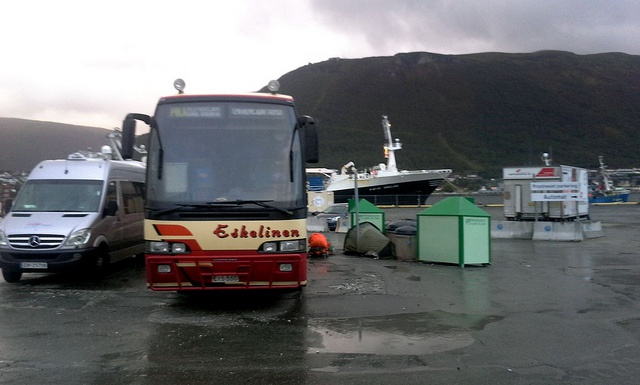Describe the objects in this image and their specific colors. I can see bus in white, gray, black, maroon, and darkgray tones, truck in white, black, gray, lavender, and darkgray tones, boat in white, black, gray, lightgray, and darkgray tones, boat in white, gray, darkblue, and black tones, and truck in white, darkgray, lightgray, and gray tones in this image. 